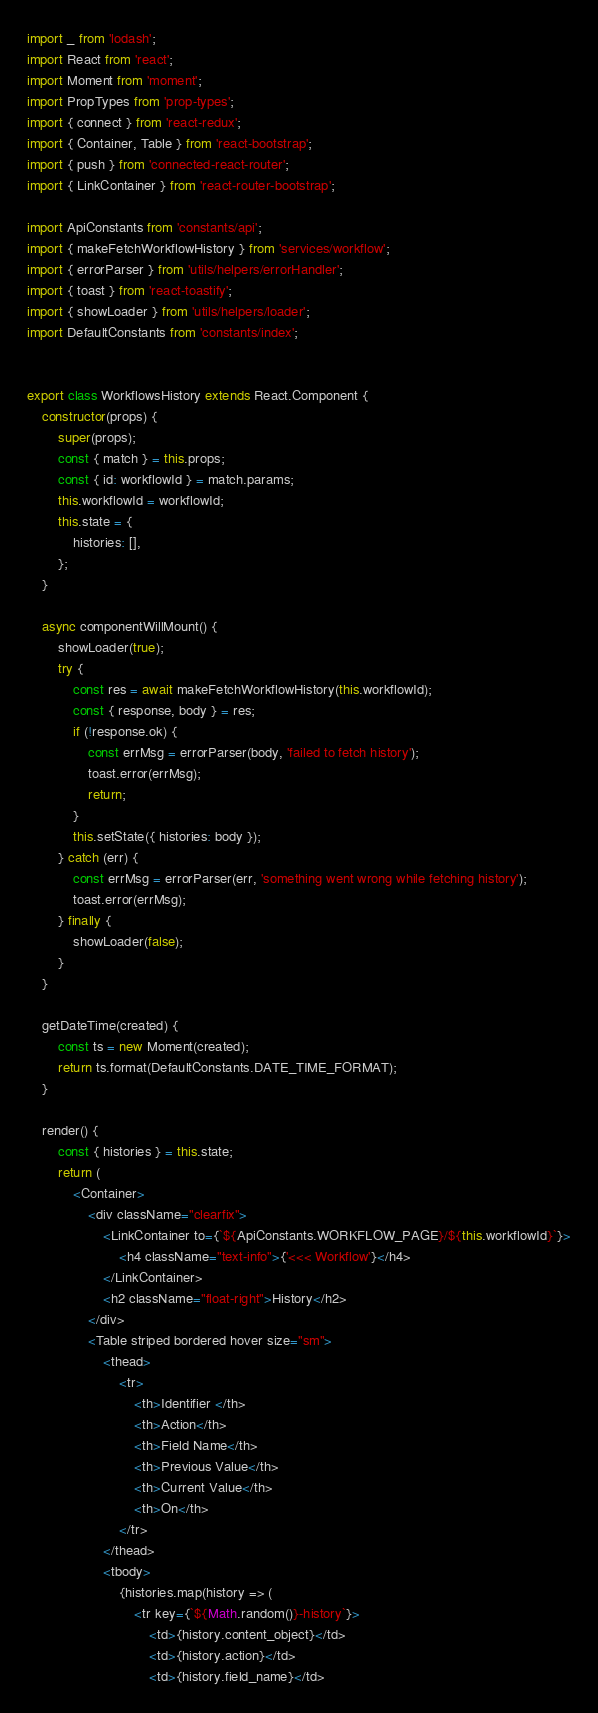<code> <loc_0><loc_0><loc_500><loc_500><_JavaScript_>import _ from 'lodash';
import React from 'react';
import Moment from 'moment';
import PropTypes from 'prop-types';
import { connect } from 'react-redux';
import { Container, Table } from 'react-bootstrap';
import { push } from 'connected-react-router';
import { LinkContainer } from 'react-router-bootstrap';

import ApiConstants from 'constants/api';
import { makeFetchWorkflowHistory } from 'services/workflow';
import { errorParser } from 'utils/helpers/errorHandler';
import { toast } from 'react-toastify';
import { showLoader } from 'utils/helpers/loader';
import DefaultConstants from 'constants/index';


export class WorkflowsHistory extends React.Component {
    constructor(props) {
        super(props);
        const { match } = this.props;
        const { id: workflowId } = match.params;
        this.workflowId = workflowId;
        this.state = {
            histories: [],
        };
    }

    async componentWillMount() {
        showLoader(true);
        try {
            const res = await makeFetchWorkflowHistory(this.workflowId);
            const { response, body } = res;
            if (!response.ok) {
                const errMsg = errorParser(body, 'failed to fetch history');
                toast.error(errMsg);
                return;
            }
            this.setState({ histories: body });
        } catch (err) {
            const errMsg = errorParser(err, 'something went wrong while fetching history');
            toast.error(errMsg);
        } finally {
            showLoader(false);
        }
    }

    getDateTime(created) {
        const ts = new Moment(created);
        return ts.format(DefaultConstants.DATE_TIME_FORMAT);
    }

    render() {
        const { histories } = this.state;
        return (
            <Container>
                <div className="clearfix">
                    <LinkContainer to={`${ApiConstants.WORKFLOW_PAGE}/${this.workflowId}`}>
                        <h4 className="text-info">{'<<< Workflow'}</h4>
                    </LinkContainer>
                    <h2 className="float-right">History</h2>
                </div>
                <Table striped bordered hover size="sm">
                    <thead>
                        <tr>
                            <th>Identifier </th>
                            <th>Action</th>
                            <th>Field Name</th>
                            <th>Previous Value</th>
                            <th>Current Value</th>
                            <th>On</th>
                        </tr>
                    </thead>
                    <tbody>
                        {histories.map(history => (
                            <tr key={`${Math.random()}-history`}>
                                <td>{history.content_object}</td>
                                <td>{history.action}</td>
                                <td>{history.field_name}</td></code> 